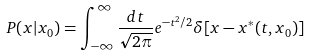<formula> <loc_0><loc_0><loc_500><loc_500>P ( x | x _ { 0 } ) = \int _ { - \infty } ^ { \infty } \frac { d t } { \sqrt { 2 \pi } } e ^ { - t ^ { 2 } / 2 } \delta [ x - x ^ { * } ( t , x _ { 0 } ) ]</formula> 